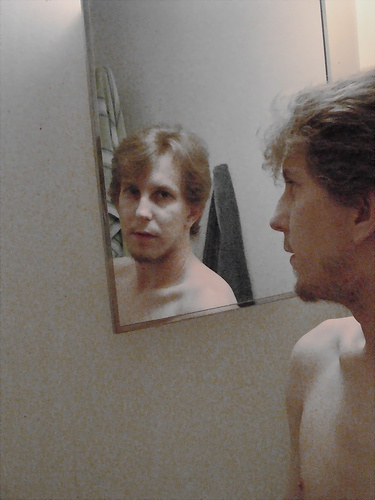Describe the objects in this image and their specific colors. I can see people in darkgray, gray, maroon, and black tones in this image. 